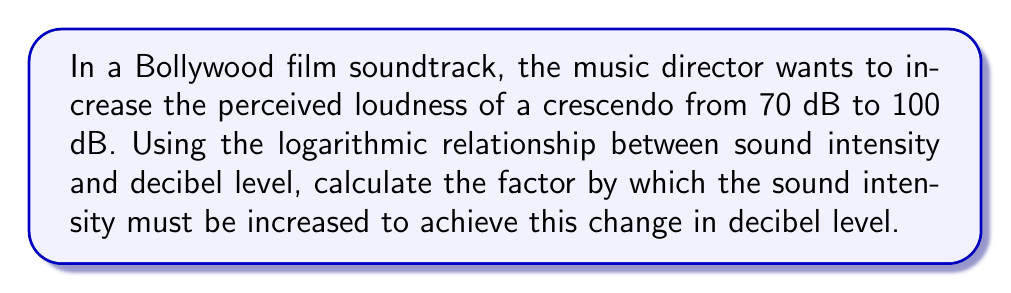Help me with this question. Let's approach this step-by-step:

1) The relationship between sound intensity (I) and decibel level (dB) is given by the equation:

   $$ dB = 10 \log_{10}\left(\frac{I}{I_0}\right) $$

   where $I_0$ is the reference intensity.

2) We need to find the ratio of final intensity ($I_2$) to initial intensity ($I_1$). Let's call this ratio $x$:

   $$ x = \frac{I_2}{I_1} $$

3) We can write two equations for the initial and final states:

   $$ 70 = 10 \log_{10}\left(\frac{I_1}{I_0}\right) $$
   $$ 100 = 10 \log_{10}\left(\frac{I_2}{I_0}\right) $$

4) Subtracting the first equation from the second:

   $$ 100 - 70 = 10 \log_{10}\left(\frac{I_2}{I_0}\right) - 10 \log_{10}\left(\frac{I_1}{I_0}\right) $$

5) Using the logarithm property $\log_a(M) - \log_a(N) = \log_a(\frac{M}{N})$:

   $$ 30 = 10 \log_{10}\left(\frac{I_2}{I_1}\right) = 10 \log_{10}(x) $$

6) Solving for $x$:

   $$ 3 = \log_{10}(x) $$
   $$ 10^3 = x $$

7) Therefore, the sound intensity must be increased by a factor of 1000.
Answer: 1000 